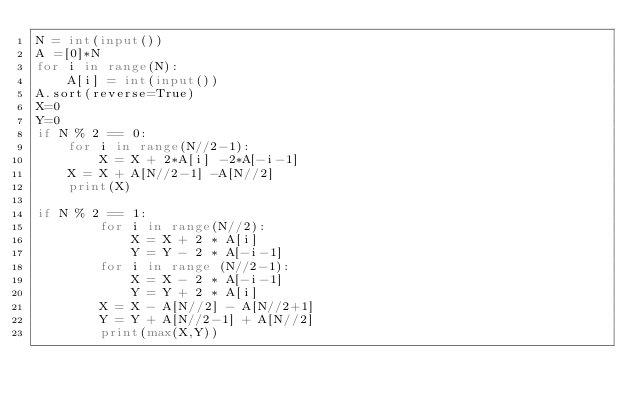Convert code to text. <code><loc_0><loc_0><loc_500><loc_500><_Python_>N = int(input())
A =[0]*N
for i in range(N):
    A[i] = int(input())
A.sort(reverse=True)
X=0
Y=0
if N % 2 == 0:
    for i in range(N//2-1):
        X = X + 2*A[i] -2*A[-i-1]
    X = X + A[N//2-1] -A[N//2]
    print(X)    

if N % 2 == 1:
        for i in range(N//2):
            X = X + 2 * A[i]
            Y = Y - 2 * A[-i-1]
        for i in range (N//2-1):
            X = X - 2 * A[-i-1]
            Y = Y + 2 * A[i]
        X = X - A[N//2] - A[N//2+1]
        Y = Y + A[N//2-1] + A[N//2]
        print(max(X,Y))</code> 